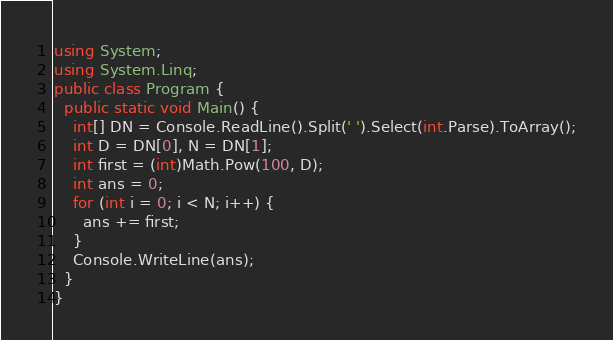<code> <loc_0><loc_0><loc_500><loc_500><_C#_>using System;
using System.Linq;
public class Program {
  public static void Main() {
    int[] DN = Console.ReadLine().Split(' ').Select(int.Parse).ToArray();
    int D = DN[0], N = DN[1];
    int first = (int)Math.Pow(100, D);
    int ans = 0;
    for (int i = 0; i < N; i++) {
      ans += first;
    }
    Console.WriteLine(ans);
  }
}
</code> 